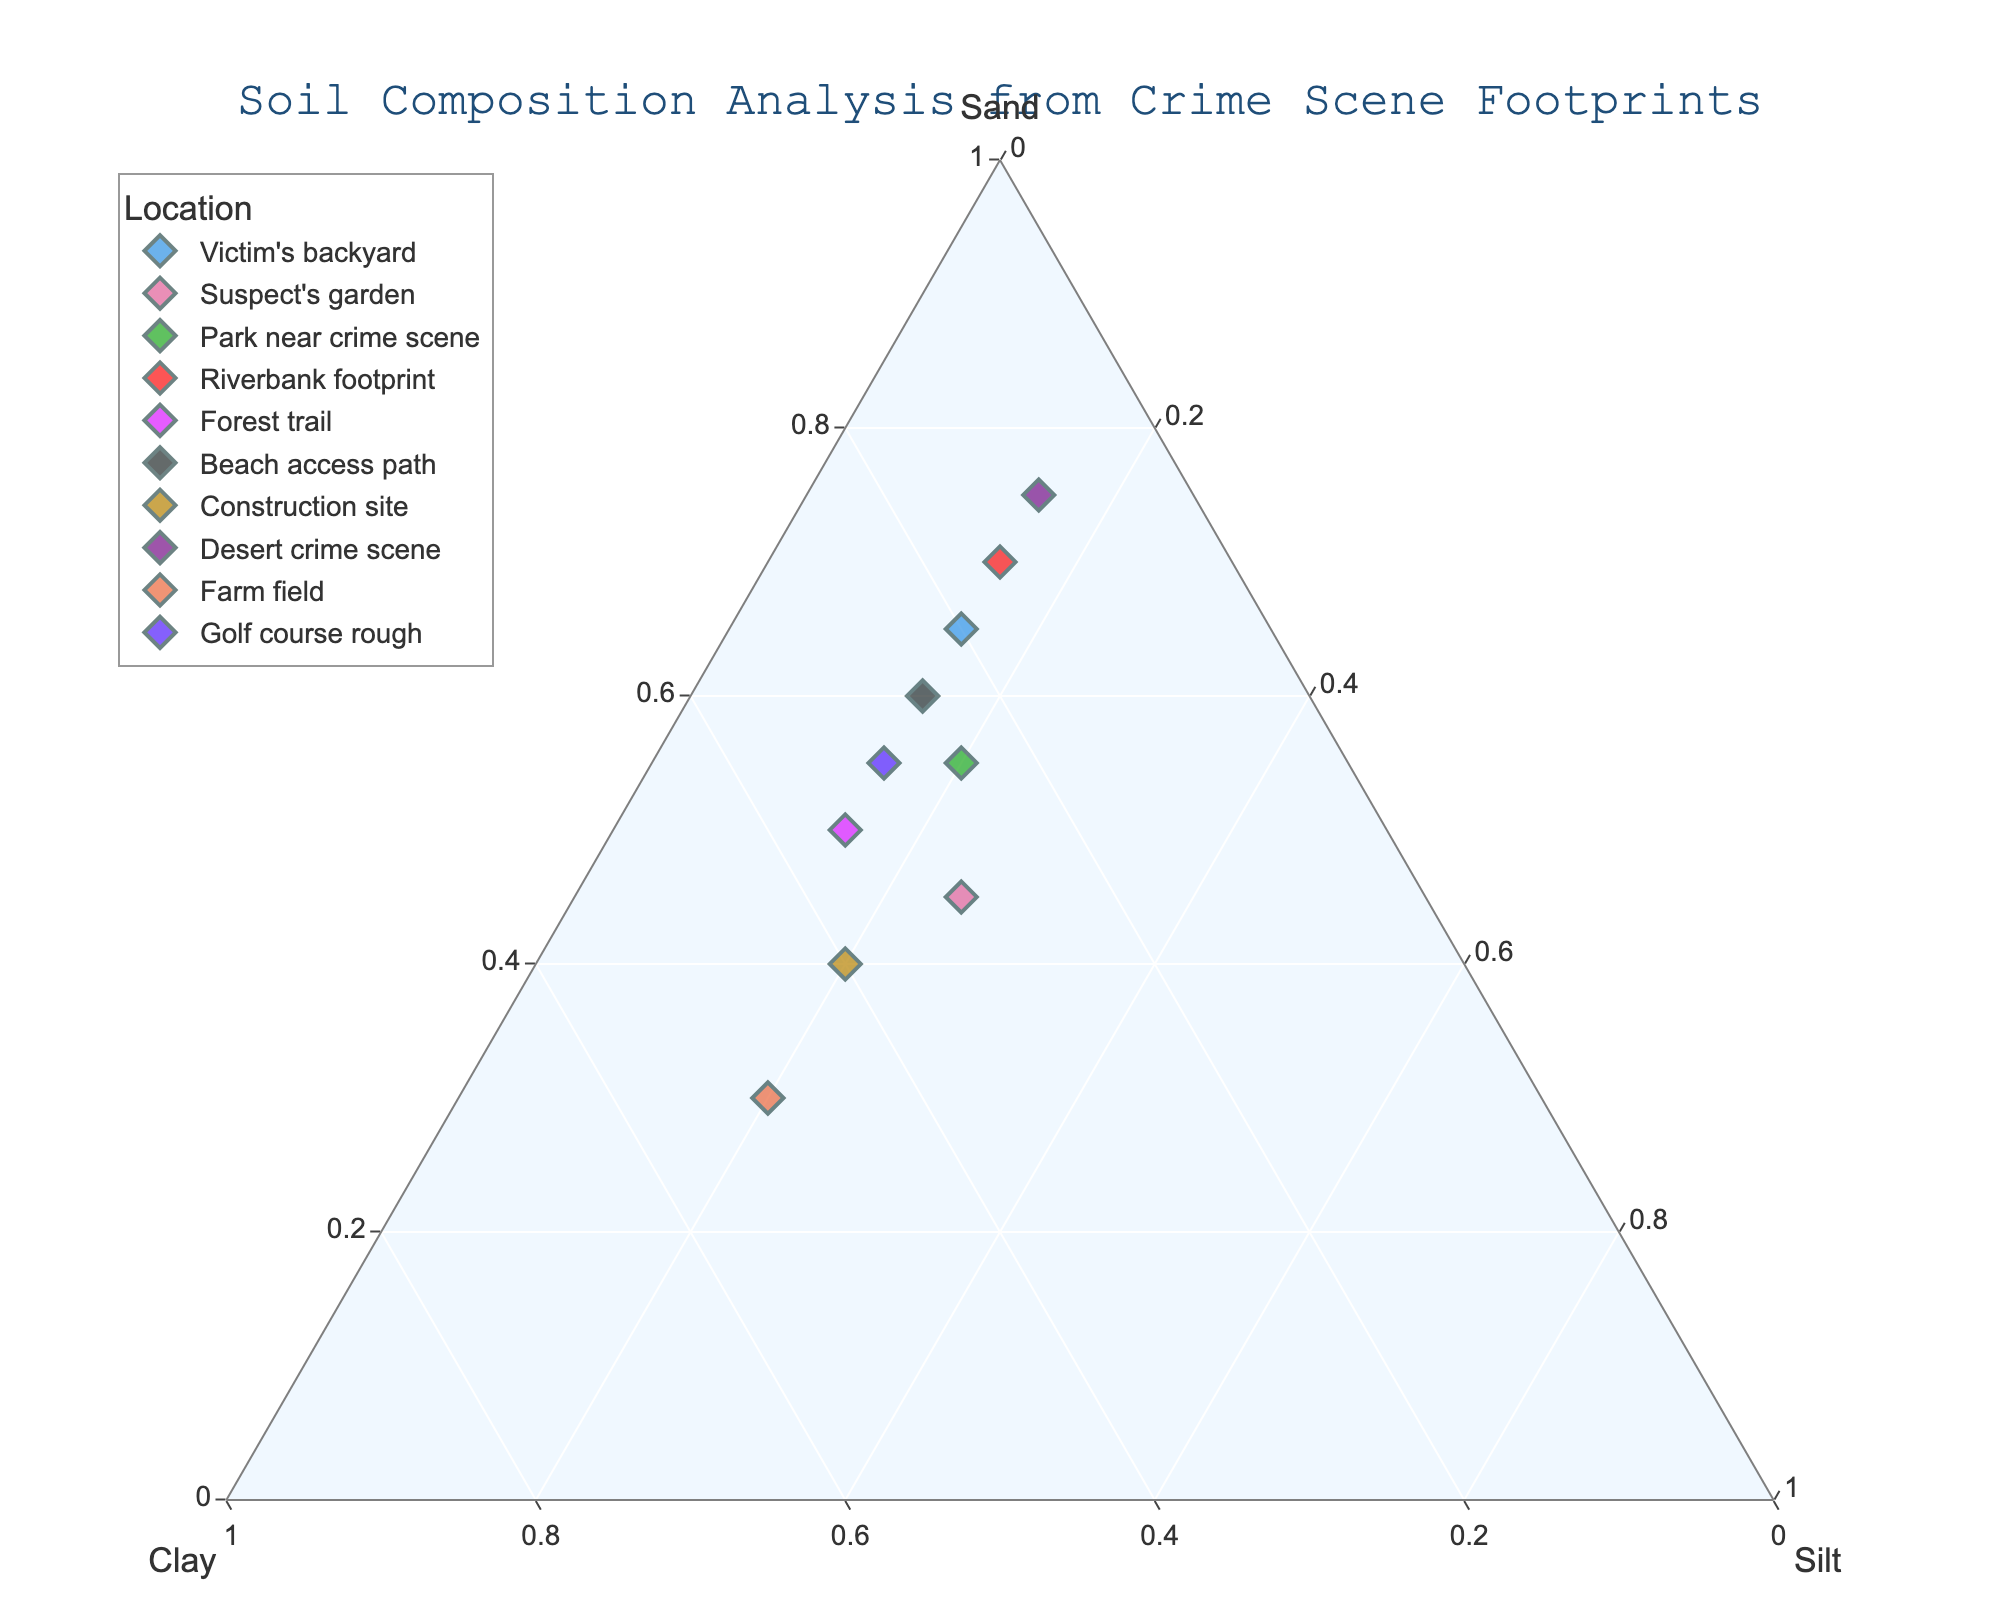what is the title of the figure? The title of the figure is present at the top center in a larger font and reads "Soil Composition Analysis from Crime Scene Footprints."
Answer: Soil Composition Analysis from Crime Scene Footprints which location has the highest sand content? The points on the ternary plot are labeled by location, and the one closest to the "Sand" vertex with the value of 75 is labeled "Desert crime scene".
Answer: Desert crime scene How many locations have a clay content greater than 30%? By examining the ternary plot, the locations whose points fall closer to the "Clay" axis greater than 30% are: "Suspect's garden", "Forest trail", "Construction site", "Farm field", and "Golf course rough".
Answer: 5 which location has the nearest composition to Beach access path's soil? Identify the point labeled "Beach access path" and locate the point nearest to it. The closest point is "Victim's backyard".
Answer: Victim's backyard Are there any locations with silt content equal to 20%? On the ternary plot, locate points along the "Silt" axis at 20%. The locations with exactly 20% silt are "Park near crime scene," "Construction site," and "Farm field".
Answer: Yes What's the average sand content of the locations "Suspect's garden" and "Construction site"? Add the sand contents of "Suspect's garden" (45) and "Construction site" (40), then divide by two. So, (45 + 40) / 2 = 42.5.
Answer: 42.5 Which location has the highest clay content, and what is its value? Find the point closest to the "Clay" vertex, which is farthest from "Sand" and "Silt". The point labeled "Farm field" has 50% clay.
Answer: Farm field, 50% Compare the sand content between "Park near crime scene" and "Riverbank footprint". Which has more? Locate both points and compare their positions relative to the "Sand" axis. "Riverbank footprint" has 70% and "Park near crime scene" has 55%.
Answer: Riverbank footprint What is the total clay content of "Victim's backyard", "Desert crime scene", and "Golf course rough"? Sum the clay contents: "Victim's backyard" (20), "Desert crime scene" (10), and "Golf course rough" (30). So, 20 + 10 + 30 = 60.
Answer: 60 Which location has the nearest composition to the ideal sandy loam texture (70% sand, 15% clay, and 15% silt)? The closest point to (70, 15, 15) is the "Riverbank footprint".
Answer: Riverbank footprint 